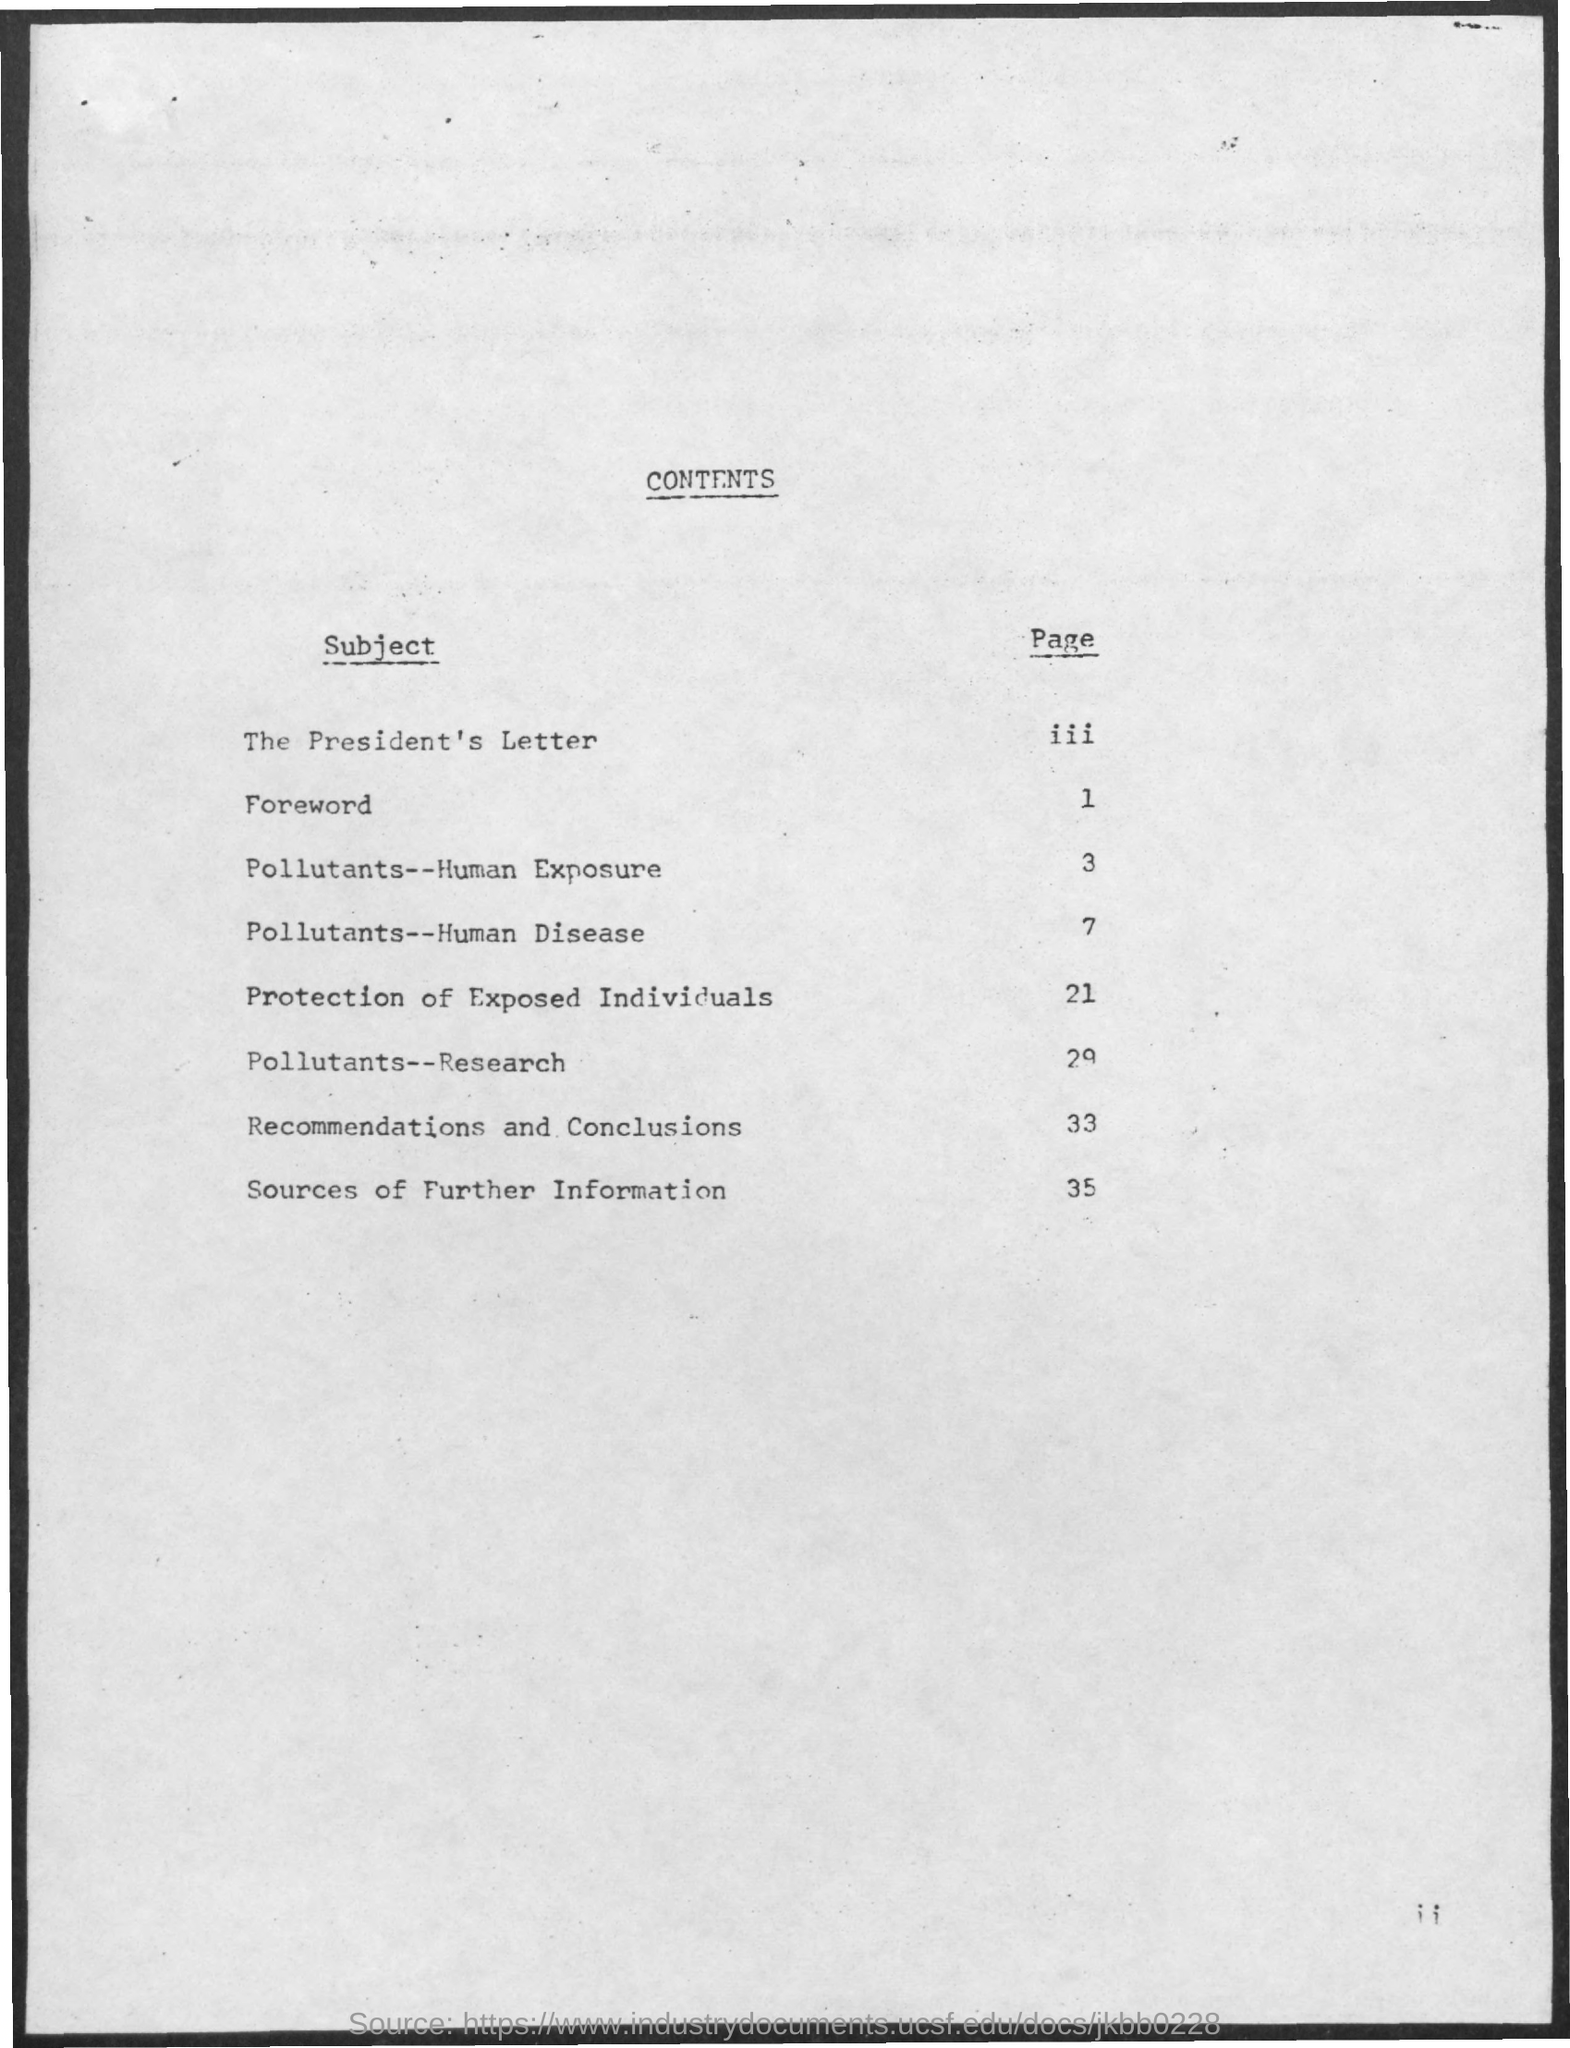What might be the significance of starting the document with 'The President's Letter'? Starting with 'The President's Letter' suggests that the document likely holds significant importance and may have originated from a high-level governmental initiative. It sets a formal and authoritative tone, indicating the critical nature of the topics discussed within. 